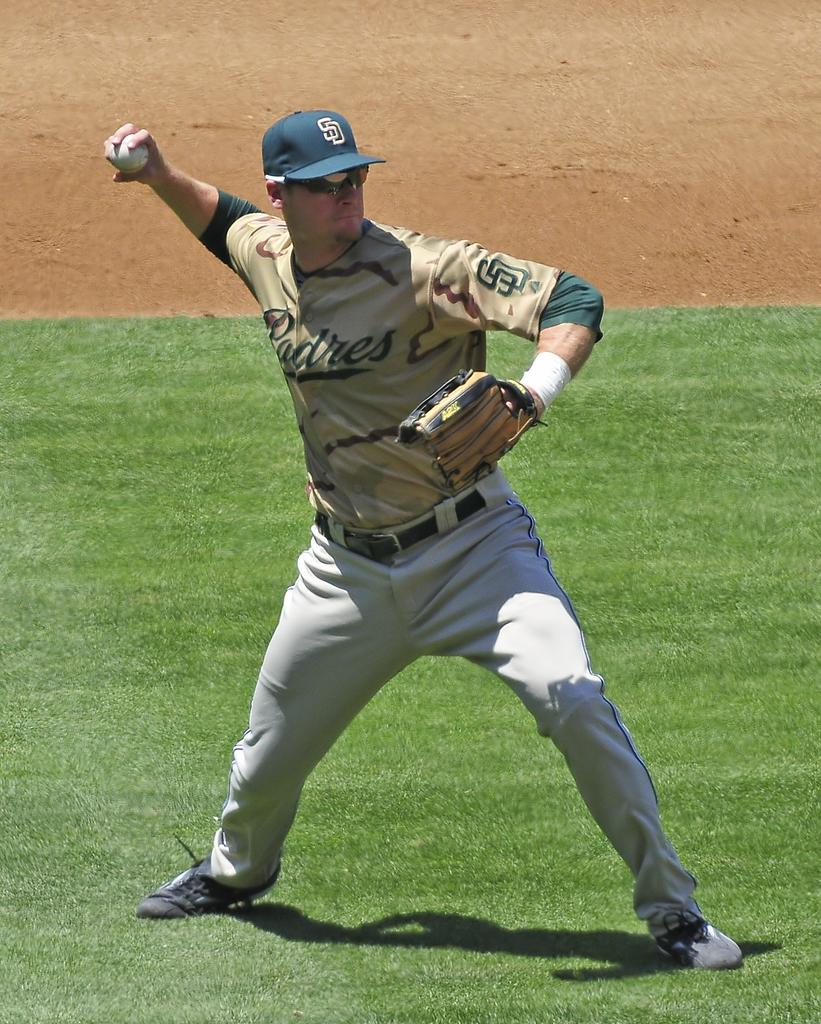<image>
Provide a brief description of the given image. A San Diego Padres baseball player throws the ball. 